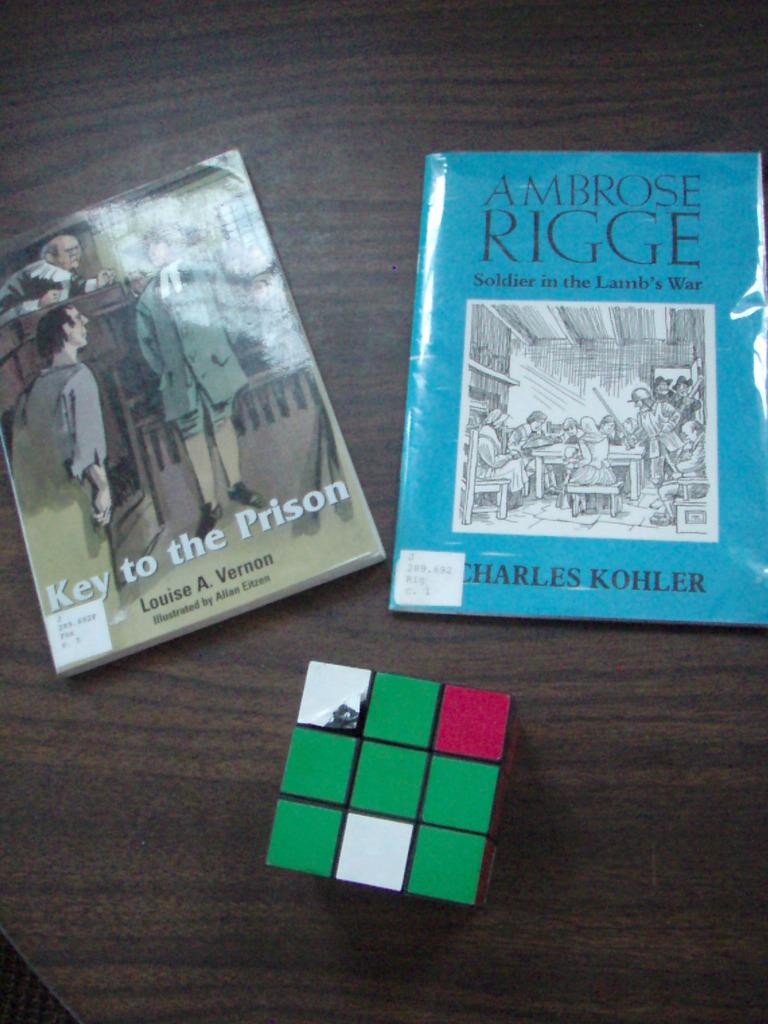<image>
Render a clear and concise summary of the photo. Two books, Key to the Prison and Ambrose Rigge, sit on a table next to a Rubik's Cube. 